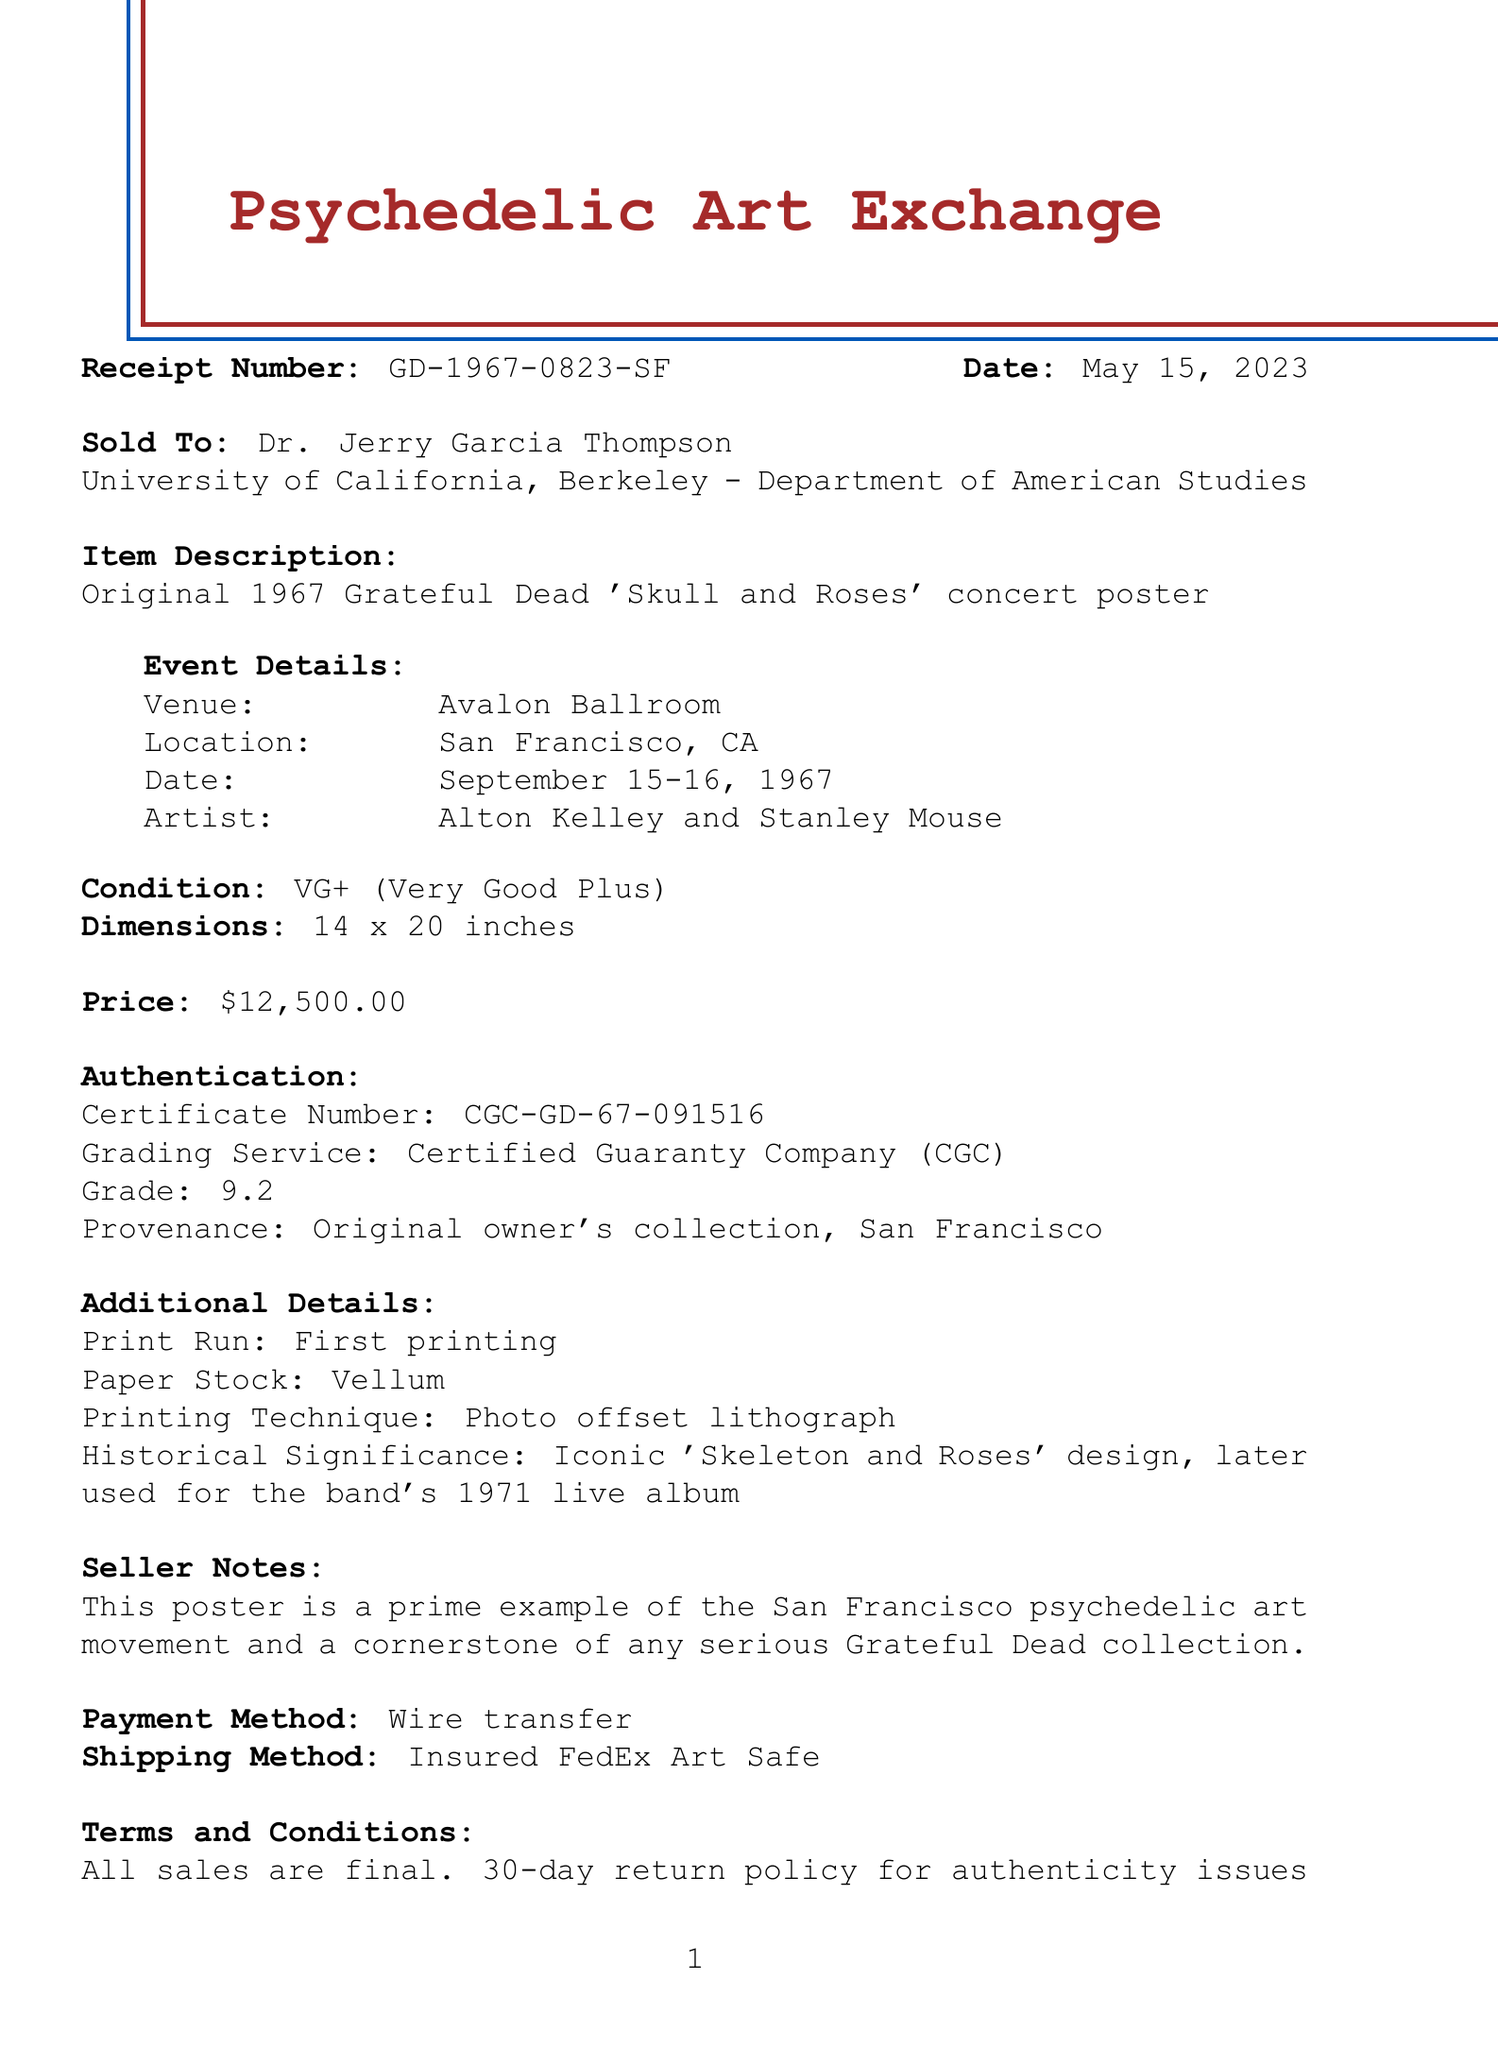What is the receipt number? The receipt number is a unique identifier for this purchase, found at the top of the document.
Answer: GD-1967-0823-SF Who is the buyer? The buyer's name is listed under the "Sold To" section of the receipt.
Answer: Dr. Jerry Garcia Thompson What is the purchase price? The purchase price is clearly stated in the receipt.
Answer: $12,500.00 What is the condition of the poster? The condition is noted in a specific section of the receipt.
Answer: VG+ (Very Good Plus) What is the historical significance mentioned? The historical significance provides context for the poster's importance in the Grateful Dead's legacy, noted in the additional details section.
Answer: Iconic 'Skeleton and Roses' design, later used for the band's 1971 live album When was the concert poster originally from? The original event date is mentioned in the "Event Details" section.
Answer: September 15-16, 1967 What method was used for payment? The payment method is explicitly stated in the receipt.
Answer: Wire transfer What was the shipping method? The shipping method is also clearly listed on the document.
Answer: Insured FedEx Art Safe What is the seller's name? The seller's name is found at the end of the receipt.
Answer: Timothy Leary Johnson 